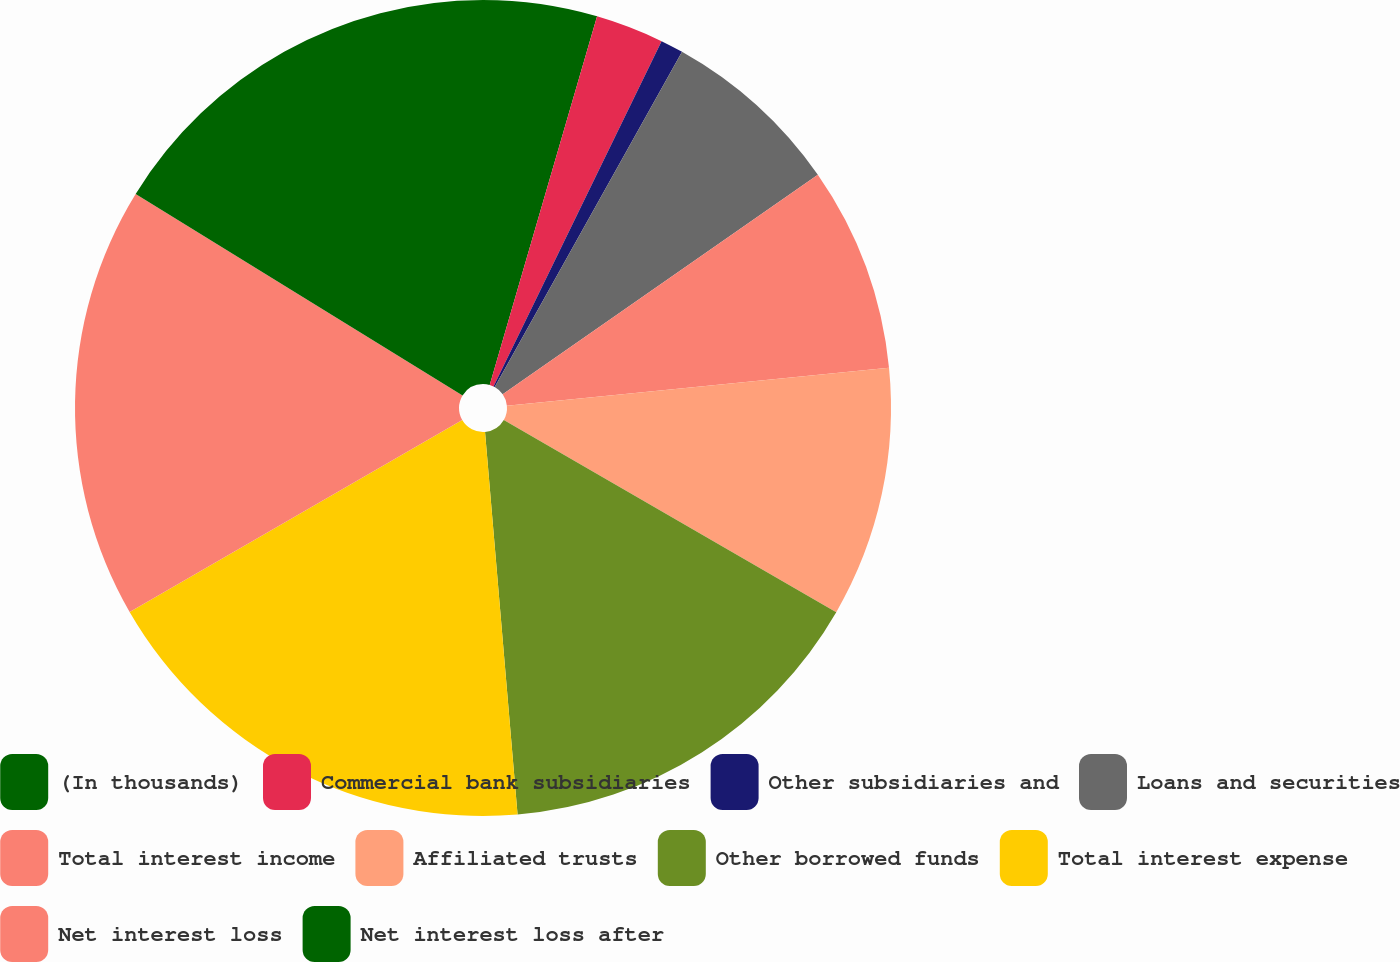<chart> <loc_0><loc_0><loc_500><loc_500><pie_chart><fcel>(In thousands)<fcel>Commercial bank subsidiaries<fcel>Other subsidiaries and<fcel>Loans and securities<fcel>Total interest income<fcel>Affiliated trusts<fcel>Other borrowed funds<fcel>Total interest expense<fcel>Net interest loss<fcel>Net interest loss after<nl><fcel>4.51%<fcel>2.7%<fcel>0.9%<fcel>7.21%<fcel>8.11%<fcel>9.91%<fcel>15.31%<fcel>18.02%<fcel>17.12%<fcel>16.21%<nl></chart> 